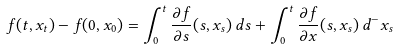Convert formula to latex. <formula><loc_0><loc_0><loc_500><loc_500>f ( t , x _ { t } ) - f ( 0 , x _ { 0 } ) = \int _ { 0 } ^ { t } \frac { \partial f } { \partial s } ( s , x _ { s } ) \, d { s } + \int _ { 0 } ^ { t } \frac { \partial f } { \partial x } ( s , x _ { s } ) \, d ^ { - } x _ { s }</formula> 